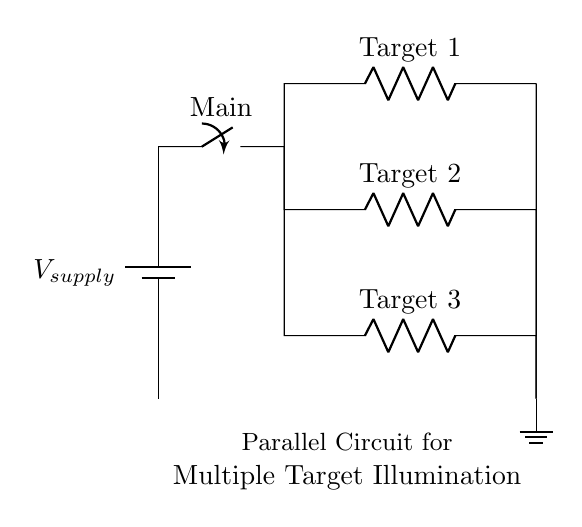What is the type of circuit shown? The circuit is a parallel circuit, which can be identified by the separate branches that provide multiple pathways for current to flow. In this diagram, each target is connected in parallel to the power supply, allowing independent operation.
Answer: Parallel How many targets are illustrated in the circuit? The circuit diagram shows three targets labeled Target 1, Target 2, and Target 3. Each target is placed on a separate branch of the parallel circuit, indicating that they can operate independently of one another.
Answer: Three What is the role of the main switch? The main switch controls the power supply to the entire circuit, allowing the user to turn on or off the illumination for all targets simultaneously. When the switch is closed, power flows to each of the parallel branches.
Answer: Control What happens if one target fails? If one target fails (such as an open circuit in one branch), the other targets will continue to function, as they are independently connected in parallel. This characteristic of parallel circuits allows for continued operation despite individual component failure.
Answer: Continues operation Which component provides the power for the circuit? The battery in the circuit diagram is the component that provides the power supply for the circuit. It generates the voltage necessary to illuminate the targets.
Answer: Battery What is the voltage rating expected in a typical shooting range circuit? While the exact voltage rating is not specified in the given data, typically, such circuits might use standard voltages like twelve volts or twenty-four volts, which are common in low-voltage illumination systems.
Answer: Commonly twelve or twenty-four volts What does the ground symbol indicate in this circuit? The ground symbol represents the reference point in the circuit; it is the return path for the current. In this diagram, it indicates that all the current returning from the targets completes the circuit back to ground level.
Answer: Reference point 